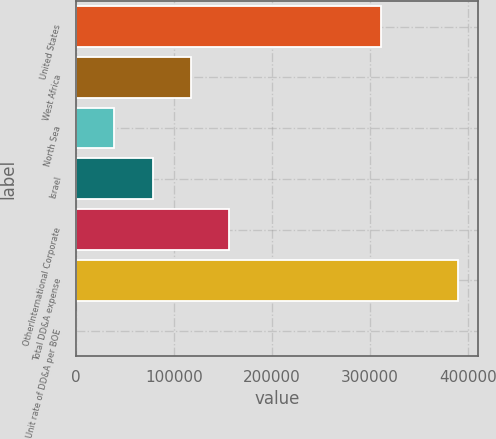<chart> <loc_0><loc_0><loc_500><loc_500><bar_chart><fcel>United States<fcel>West Africa<fcel>North Sea<fcel>Israel<fcel>OtherInternational Corporate<fcel>Total DD&A expense<fcel>Unit rate of DD&A per BOE<nl><fcel>311153<fcel>117168<fcel>39061.2<fcel>78114.9<fcel>156222<fcel>390544<fcel>7.55<nl></chart> 